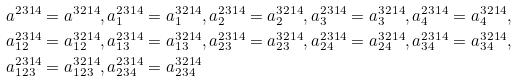<formula> <loc_0><loc_0><loc_500><loc_500>a ^ { 2 3 1 4 } & = a ^ { 3 2 1 4 } , a _ { 1 } ^ { 2 3 1 4 } = a _ { 1 } ^ { 3 2 1 4 } , a _ { 2 } ^ { 2 3 1 4 } = a _ { 2 } ^ { 3 2 1 4 } , a _ { 3 } ^ { 2 3 1 4 } = a _ { 3 } ^ { 3 2 1 4 } , a _ { 4 } ^ { 2 3 1 4 } = a _ { 4 } ^ { 3 2 1 4 } , \\ a _ { 1 2 } ^ { 2 3 1 4 } & = a _ { 1 2 } ^ { 3 2 1 4 } , a _ { 1 3 } ^ { 2 3 1 4 } = a _ { 1 3 } ^ { 3 2 1 4 } , a _ { 2 3 } ^ { 2 3 1 4 } = a _ { 2 3 } ^ { 3 2 1 4 } , a _ { 2 4 } ^ { 2 3 1 4 } = a _ { 2 4 } ^ { 3 2 1 4 } , a _ { 3 4 } ^ { 2 3 1 4 } = a _ { 3 4 } ^ { 3 2 1 4 } , \\ a _ { 1 2 3 } ^ { 2 3 1 4 } & = a _ { 1 2 3 } ^ { 3 2 1 4 } , a _ { 2 3 4 } ^ { 2 3 1 4 } = a _ { 2 3 4 } ^ { 3 2 1 4 }</formula> 